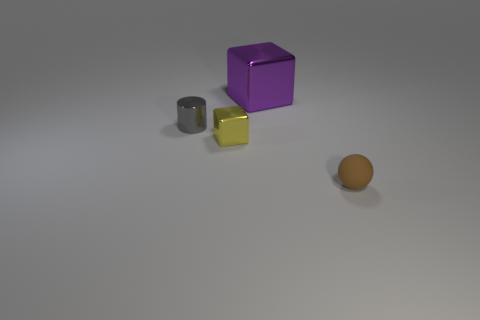What number of things are both to the left of the sphere and on the right side of the small gray metal thing?
Your response must be concise. 2. There is a object that is in front of the cube that is in front of the small object behind the small shiny block; what color is it?
Provide a succinct answer. Brown. What number of other objects are the same shape as the large purple thing?
Your response must be concise. 1. There is a object that is in front of the yellow cube; is there a tiny rubber thing that is behind it?
Provide a short and direct response. No. How many matte things are either big red cylinders or large things?
Provide a succinct answer. 0. What is the object that is both to the right of the small metallic cube and in front of the big purple thing made of?
Give a very brief answer. Rubber. There is a small metallic thing that is in front of the thing that is on the left side of the small yellow thing; is there a gray cylinder that is in front of it?
Offer a terse response. No. Is there any other thing that has the same material as the purple cube?
Ensure brevity in your answer.  Yes. The purple thing that is made of the same material as the tiny gray cylinder is what shape?
Provide a succinct answer. Cube. Are there fewer large metallic objects that are to the right of the small brown thing than yellow metallic things on the right side of the tiny gray cylinder?
Your response must be concise. Yes. 